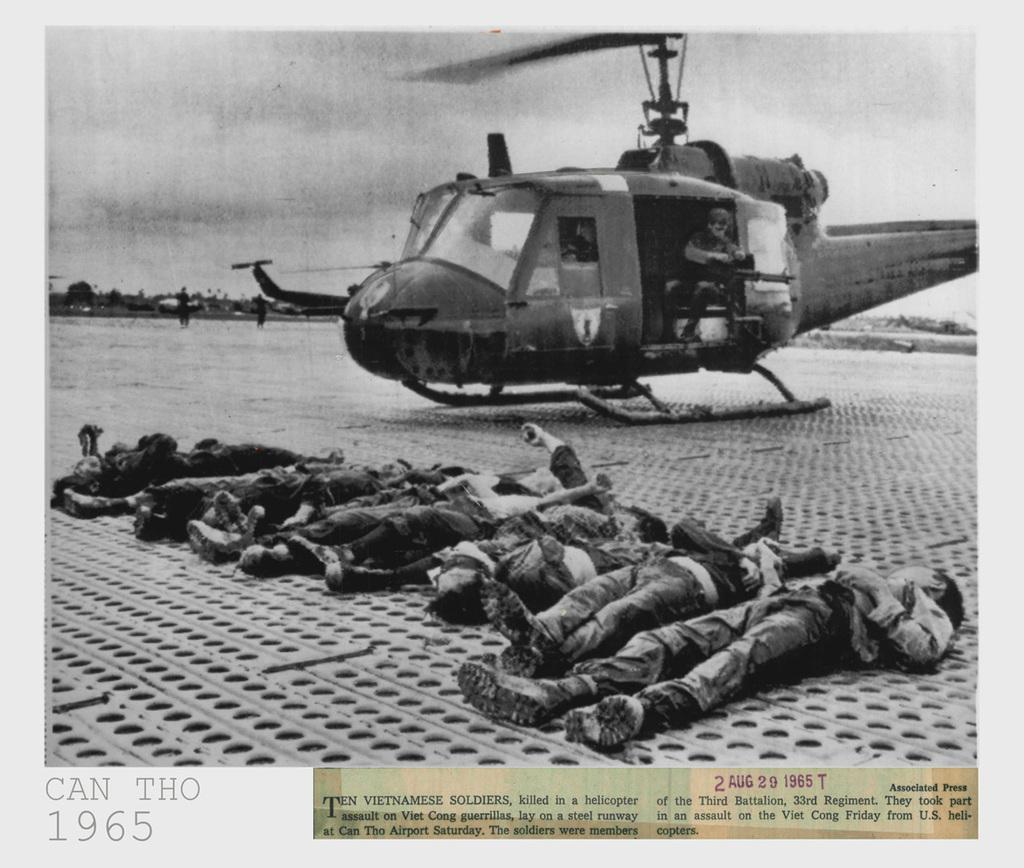Who or what can be seen in the image? There are people in the image. What else is present in the image besides the people? There is an aircraft in the image. What can be seen in the background of the image? The sky is visible in the background of the image. Is there any text or information provided in the image? Yes, there is written text at the bottom of the image. What part of the aircraft is being washed in the image? There is no indication of any washing or cleaning activity in the image; it simply shows people and an aircraft. 